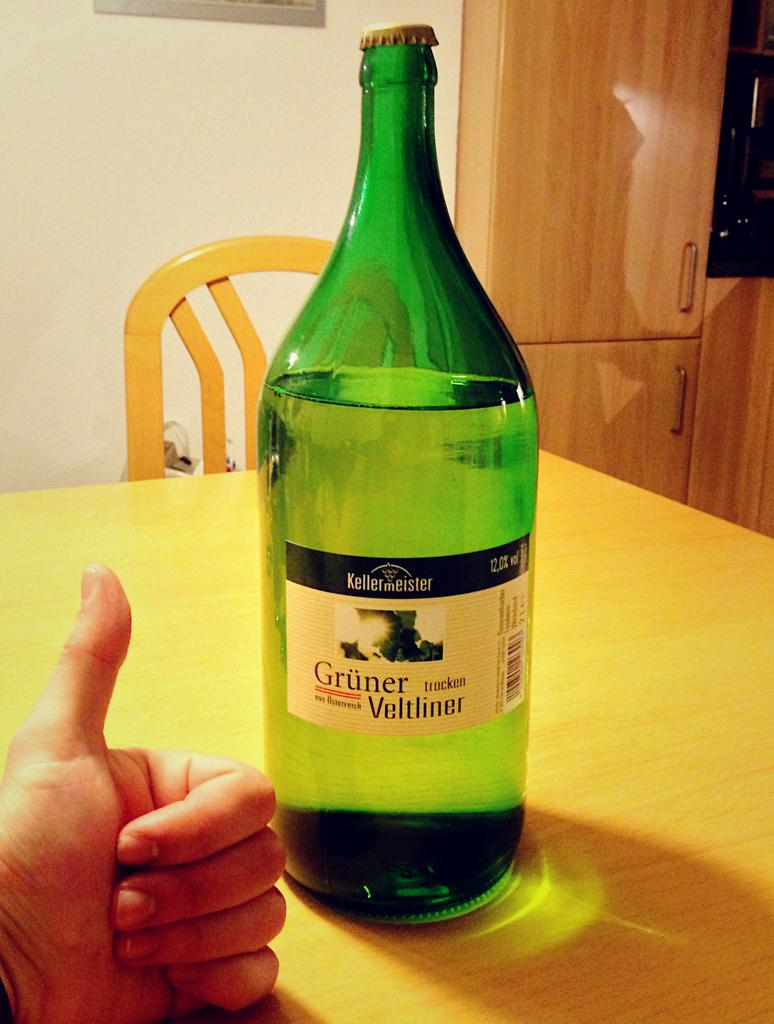<image>
Summarize the visual content of the image. A green bottle with Gruner Veltliner written on the label. 